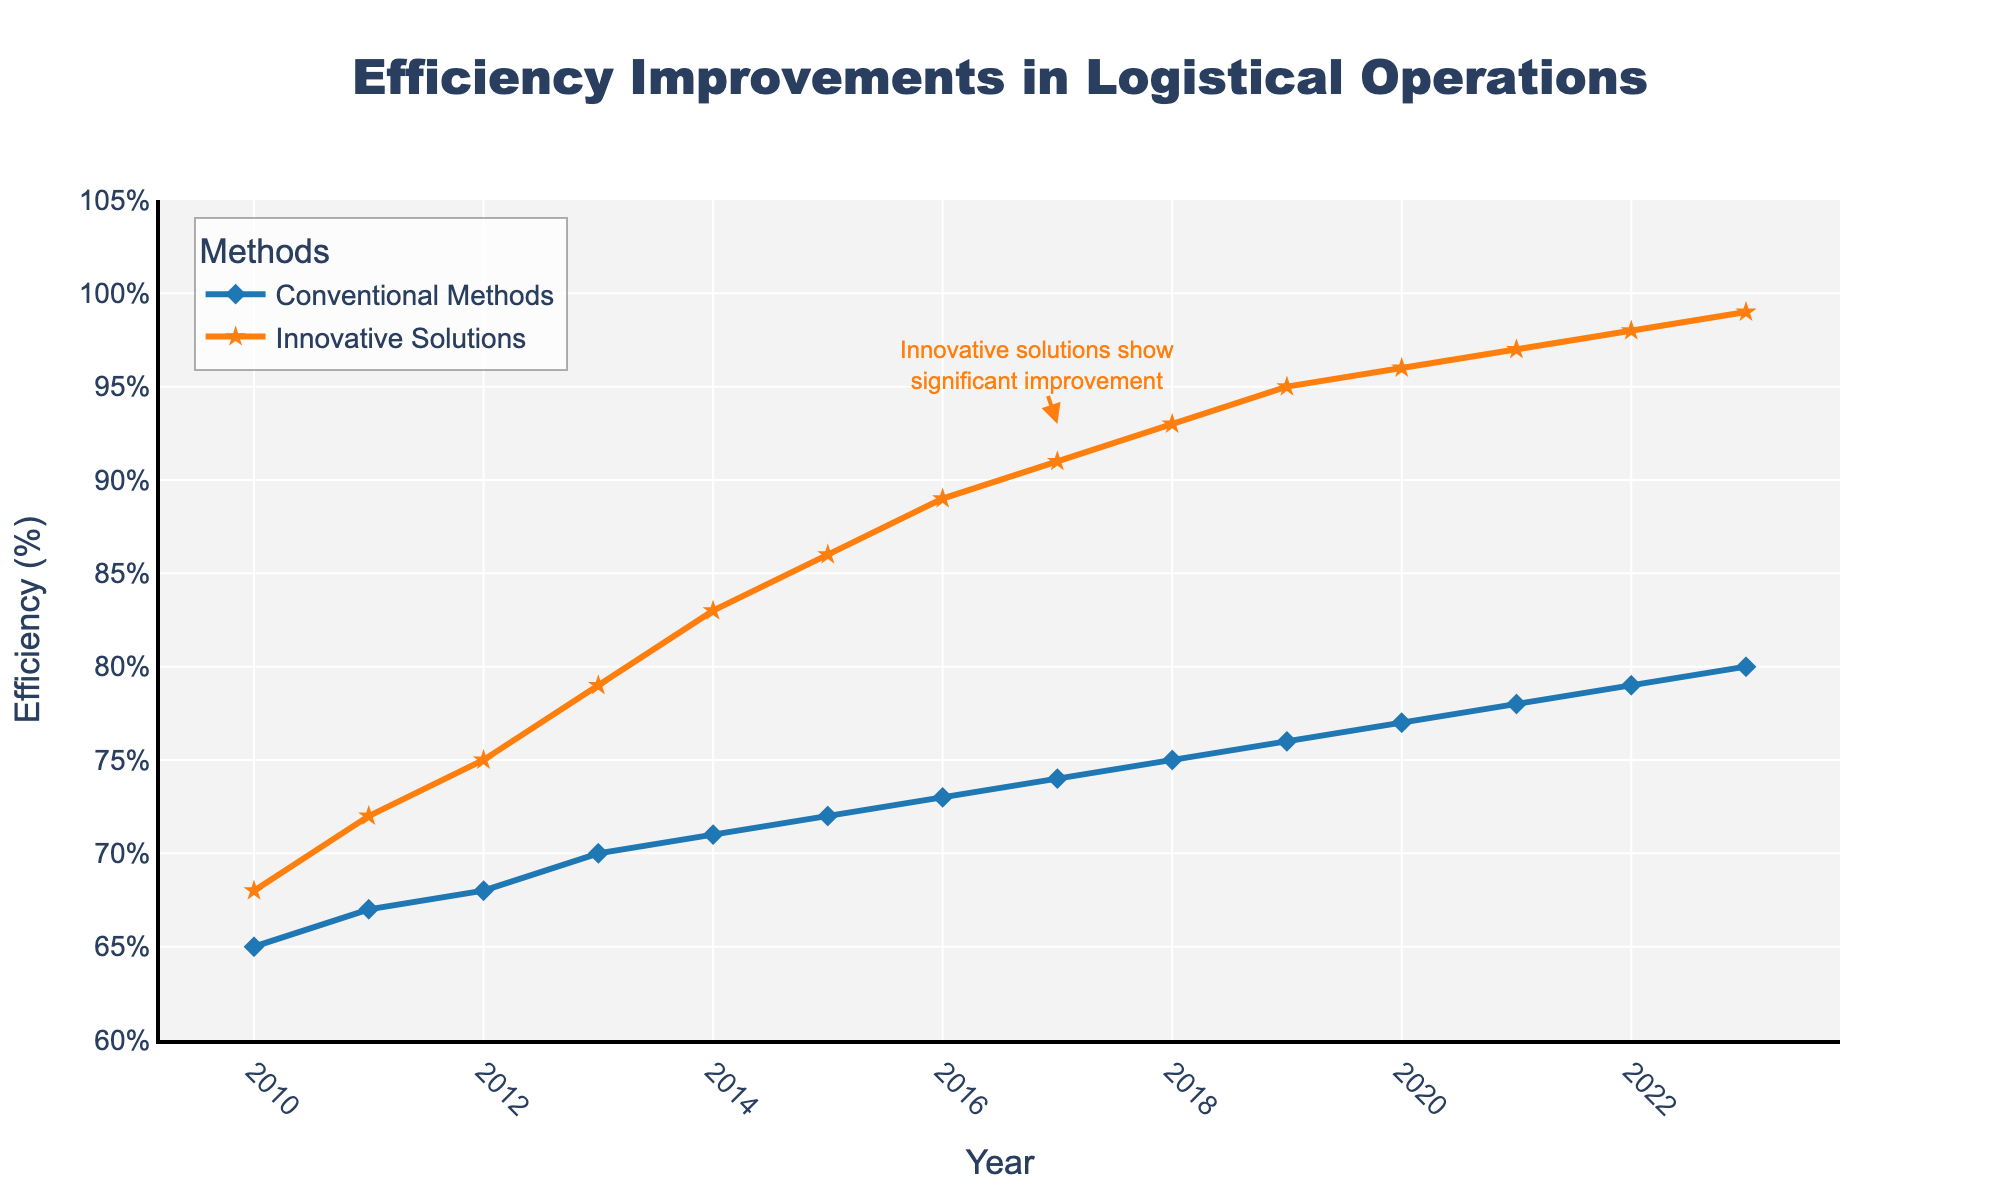Which method has the highest efficiency in the year 2023? Look at the year 2023 data points. Innovative Solutions has an efficiency of 99%, which is higher than Conventional Methods.
Answer: Innovative Solutions How much did the efficiency of Conventional Methods improve from 2010 to 2023? The efficiency for Conventional Methods in 2010 was 65%, and in 2023 it was 80%. The difference is 80% - 65% = 15%.
Answer: 15% Over which time period did Innovative Solutions see the most significant increase in efficiency? Compare the efficiency increases year by year for Innovative Solutions. The most significant increase happened between 2012 (75%) and 2013 (79%), an increase of 4%.
Answer: 2012-2013 What is the overall trend for Innovative Solutions from 2010 to 2023? From 2010 to 2023, the efficiency for Innovative Solutions increased each year, starting from 68% in 2010 to 99% in 2023.
Answer: Increasing What visual cue indicates that Innovative Solutions saw a significant improvement in efficiency? There is an annotation near the data indicating "Innovative solutions show significant improvement," accompanied by an arrow pointing to the 2017 data point.
Answer: Annotation with an arrow By how much did Conventional Methods efficiency lag behind Innovative Solutions in the year 2015? In 2015, Conventional Methods had an efficiency of 72%, and Innovative Solutions had an efficiency of 86%. The difference is 86% - 72% = 14%.
Answer: 14% What is the average efficiency of Conventional Methods across the years 2010 to 2023? Sum the efficiencies for Conventional Methods from 2010 to 2023 and divide by the number of years: (65 + 67 + 68 + 70 + 71 + 72 + 73 + 74 + 75 + 76 + 77 + 78 + 79 + 80) / 14 = 73.21%.
Answer: 73.21% In which year did both methods have their closest efficiency values? Compare the differences in efficiencies for each year. The smallest difference occurs in 2010, where Conventional Methods had 65% and Innovative Solutions had 68%, a difference of 3%.
Answer: 2010 Which method has a steeper line slope in the early years, indicating a rapid initial improvement? Comparing the slopes visually, Innovative Solutions shows a steeper incline from 2010 to 2014 compared to Conventional Methods.
Answer: Innovative Solutions How many years did it take for Conventional Methods to increase efficiency by 5% from 2010 levels? From 2010 (65%) to 2014 (71%), it took 4 years to increase efficiency by 6% (71%-65%).
Answer: 4 years 